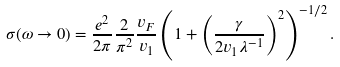Convert formula to latex. <formula><loc_0><loc_0><loc_500><loc_500>\sigma ( \omega \to 0 ) = \frac { e ^ { 2 } } { 2 \pi } \frac { 2 } { \pi ^ { 2 } } \frac { v _ { F } } { v _ { 1 } } \left ( 1 + \left ( \frac { \gamma } { 2 v _ { 1 } \lambda ^ { - 1 } } \right ) ^ { 2 } \right ) ^ { - 1 / 2 } .</formula> 